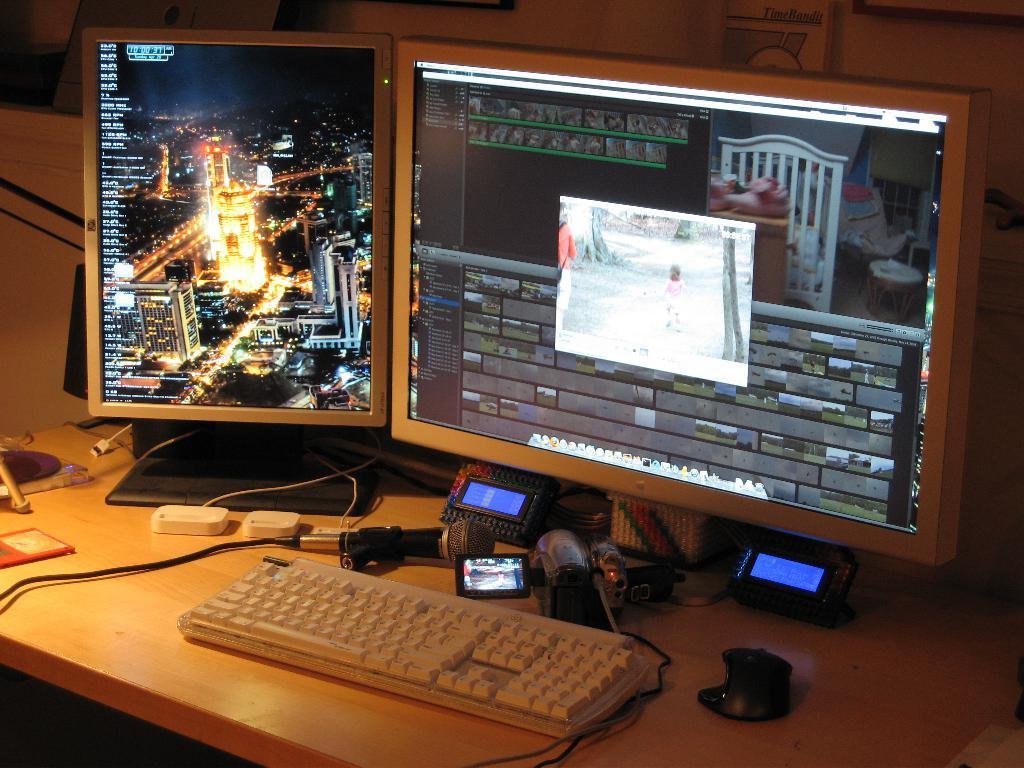What is the main subject of the image? The main subject of the image is a system. What is a prominent feature of the system? There is a display in the image. What are the input devices in the image? There are keyboards in the image. How are the devices connected in the image? There is a cable wire in the image. What is the surface on which the system is placed? There is a wooden table in the image. What device is used for audio input in the image? There is a microphone in the image. What device is used for capturing visuals in the image? There is a camera in the image. What other devices can be seen in the image? There are other devices in the image. What type of advertisement can be seen on the wooden table in the image? There is no advertisement present on the wooden table in the image. What does the pig do with the match in the image? There is no pig or match present in the image. 